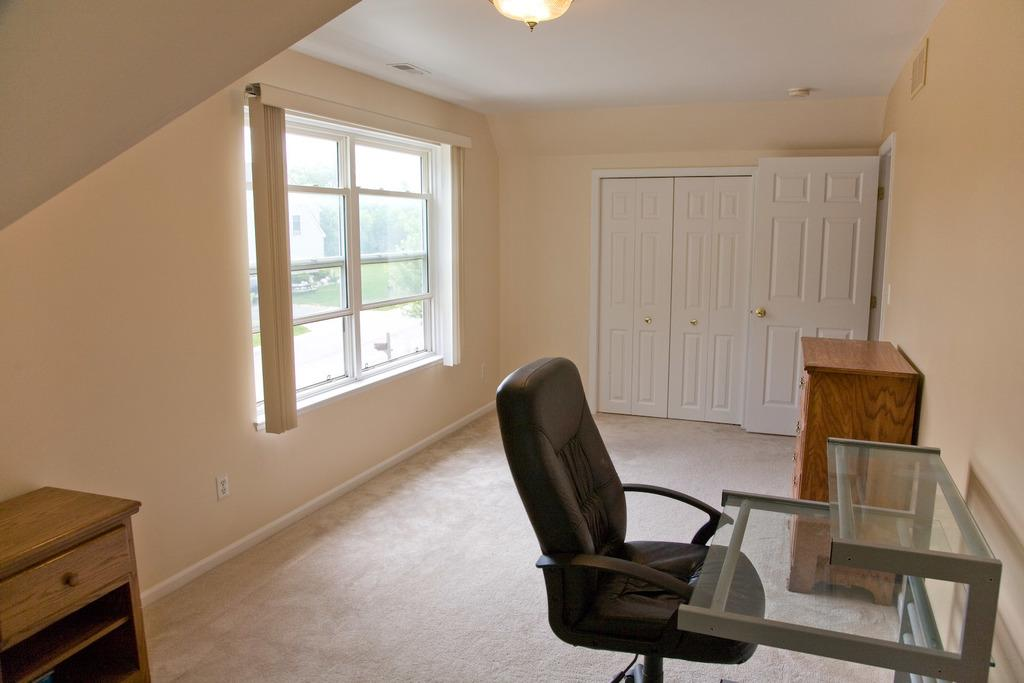What type of space is depicted in the image? There is a room. What features of the room allow for natural light and ventilation? The room has windows. What type of window treatment is present in the room? The room has curtains. How can one enter or exit the room? The room has a door. What type of furniture is present in the room for storage? The room has a cupboard. What type of furniture is present in the room for seating? The room has a chair. What type of furniture is present in the room for placing objects? The room has a table. What type of surface is present in the room for walking or standing? The room has a floor. What type of lighting is present in the room? The room has a light. What type of structure encloses the room? The room has walls. Where is the market located in the image? There is no market present in the image. What type of underground storage space is depicted in the image? There is no cellar present in the image. Who is the representative of the room in the image? The text does not mention any representative of the room in the image. 